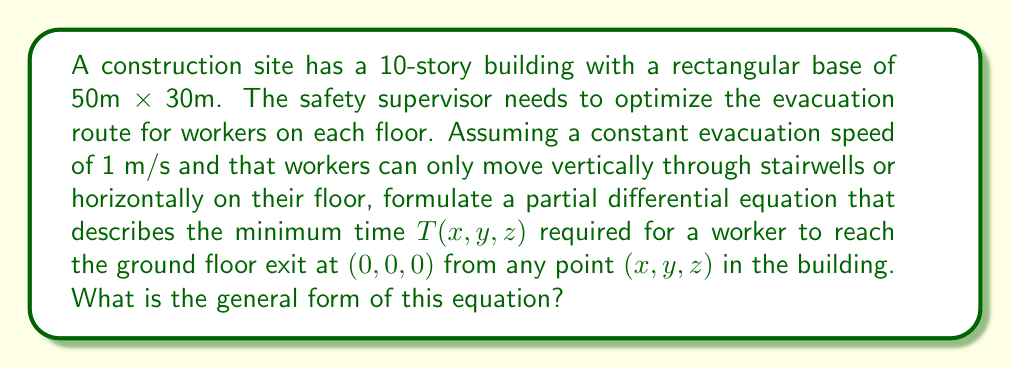Solve this math problem. To formulate the partial differential equation for the minimum evacuation time, we need to consider the following:

1. The problem is three-dimensional, with $x$ and $y$ representing horizontal coordinates and $z$ representing the vertical coordinate (floor level).

2. The evacuation speed is constant at 1 m/s in all directions.

3. Workers can only move horizontally on their current floor or vertically through stairwells.

4. We want to minimize the time $T(x,y,z)$ to reach the exit at $(0,0,0)$.

Given these conditions, we can use the Eikonal equation, which describes the propagation of wavefronts in geometrical optics. In this case, the wavefront represents the minimum time to reach any point from the exit.

The general form of the Eikonal equation in three dimensions is:

$$\left(\frac{\partial T}{\partial x}\right)^2 + \left(\frac{\partial T}{\partial y}\right)^2 + \left(\frac{\partial T}{\partial z}\right)^2 = \frac{1}{v^2}$$

Where $v$ is the propagation speed (in our case, the evacuation speed).

Since our evacuation speed is 1 m/s, we can simplify the equation to:

$$\left(\frac{\partial T}{\partial x}\right)^2 + \left(\frac{\partial T}{\partial y}\right)^2 + \left(\frac{\partial T}{\partial z}\right)^2 = 1$$

This equation states that the magnitude of the gradient of $T$ is equal to the inverse of the evacuation speed at every point in the building.

The boundary condition for this equation is:

$$T(0,0,0) = 0$$

Which represents the exit point where the evacuation time is zero.

This partial differential equation, along with the boundary condition, describes the minimum time required for a worker to reach the ground floor exit from any point in the building, taking into account the constraints of movement in the construction site.
Answer: The general form of the partial differential equation describing the minimum evacuation time $T(x,y,z)$ is:

$$\left(\frac{\partial T}{\partial x}\right)^2 + \left(\frac{\partial T}{\partial y}\right)^2 + \left(\frac{\partial T}{\partial z}\right)^2 = 1$$

with the boundary condition $T(0,0,0) = 0$. 